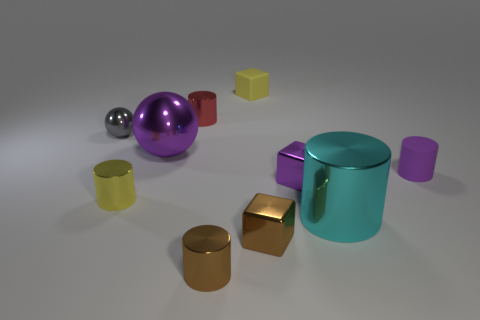What number of other cyan things are the same shape as the big cyan metallic object?
Provide a succinct answer. 0. The large metallic object that is behind the rubber object that is in front of the purple metallic thing that is left of the small yellow cube is what color?
Your answer should be very brief. Purple. Are the yellow object that is on the left side of the small red shiny thing and the small cube that is behind the small purple rubber cylinder made of the same material?
Your response must be concise. No. How many things are tiny cylinders that are left of the cyan cylinder or small purple cylinders?
Offer a very short reply. 4. How many objects are either gray cubes or small metallic cubes that are in front of the big cyan thing?
Your answer should be very brief. 1. What number of spheres have the same size as the cyan metallic cylinder?
Your response must be concise. 1. Are there fewer large cylinders that are to the left of the large purple thing than shiny things that are behind the purple cylinder?
Your answer should be very brief. Yes. How many metal objects are either cyan things or big purple balls?
Your answer should be compact. 2. The purple rubber object is what shape?
Give a very brief answer. Cylinder. There is a sphere that is the same size as the red metal cylinder; what material is it?
Give a very brief answer. Metal. 